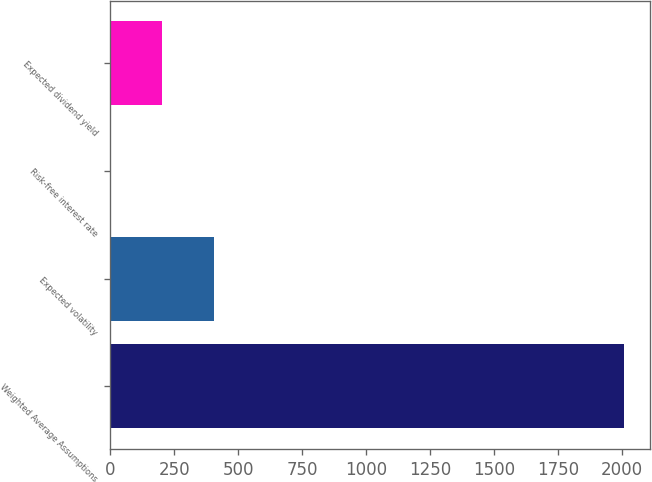Convert chart to OTSL. <chart><loc_0><loc_0><loc_500><loc_500><bar_chart><fcel>Weighted Average Assumptions<fcel>Expected volatility<fcel>Risk-free interest rate<fcel>Expected dividend yield<nl><fcel>2011<fcel>404.12<fcel>2.4<fcel>203.26<nl></chart> 